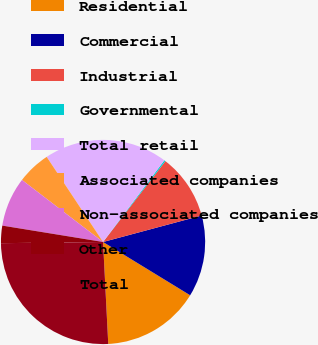<chart> <loc_0><loc_0><loc_500><loc_500><pie_chart><fcel>Residential<fcel>Commercial<fcel>Industrial<fcel>Governmental<fcel>Total retail<fcel>Associated companies<fcel>Non-associated companies<fcel>Other<fcel>Total<nl><fcel>15.45%<fcel>12.91%<fcel>10.37%<fcel>0.21%<fcel>19.55%<fcel>5.29%<fcel>7.83%<fcel>2.75%<fcel>25.62%<nl></chart> 